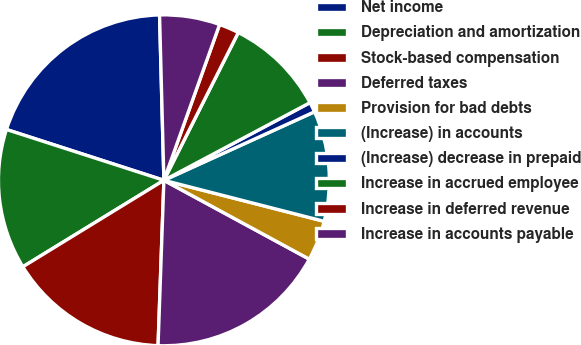<chart> <loc_0><loc_0><loc_500><loc_500><pie_chart><fcel>Net income<fcel>Depreciation and amortization<fcel>Stock-based compensation<fcel>Deferred taxes<fcel>Provision for bad debts<fcel>(Increase) in accounts<fcel>(Increase) decrease in prepaid<fcel>Increase in accrued employee<fcel>Increase in deferred revenue<fcel>Increase in accounts payable<nl><fcel>19.61%<fcel>13.72%<fcel>15.68%<fcel>17.65%<fcel>3.92%<fcel>10.78%<fcel>0.98%<fcel>9.8%<fcel>1.96%<fcel>5.88%<nl></chart> 